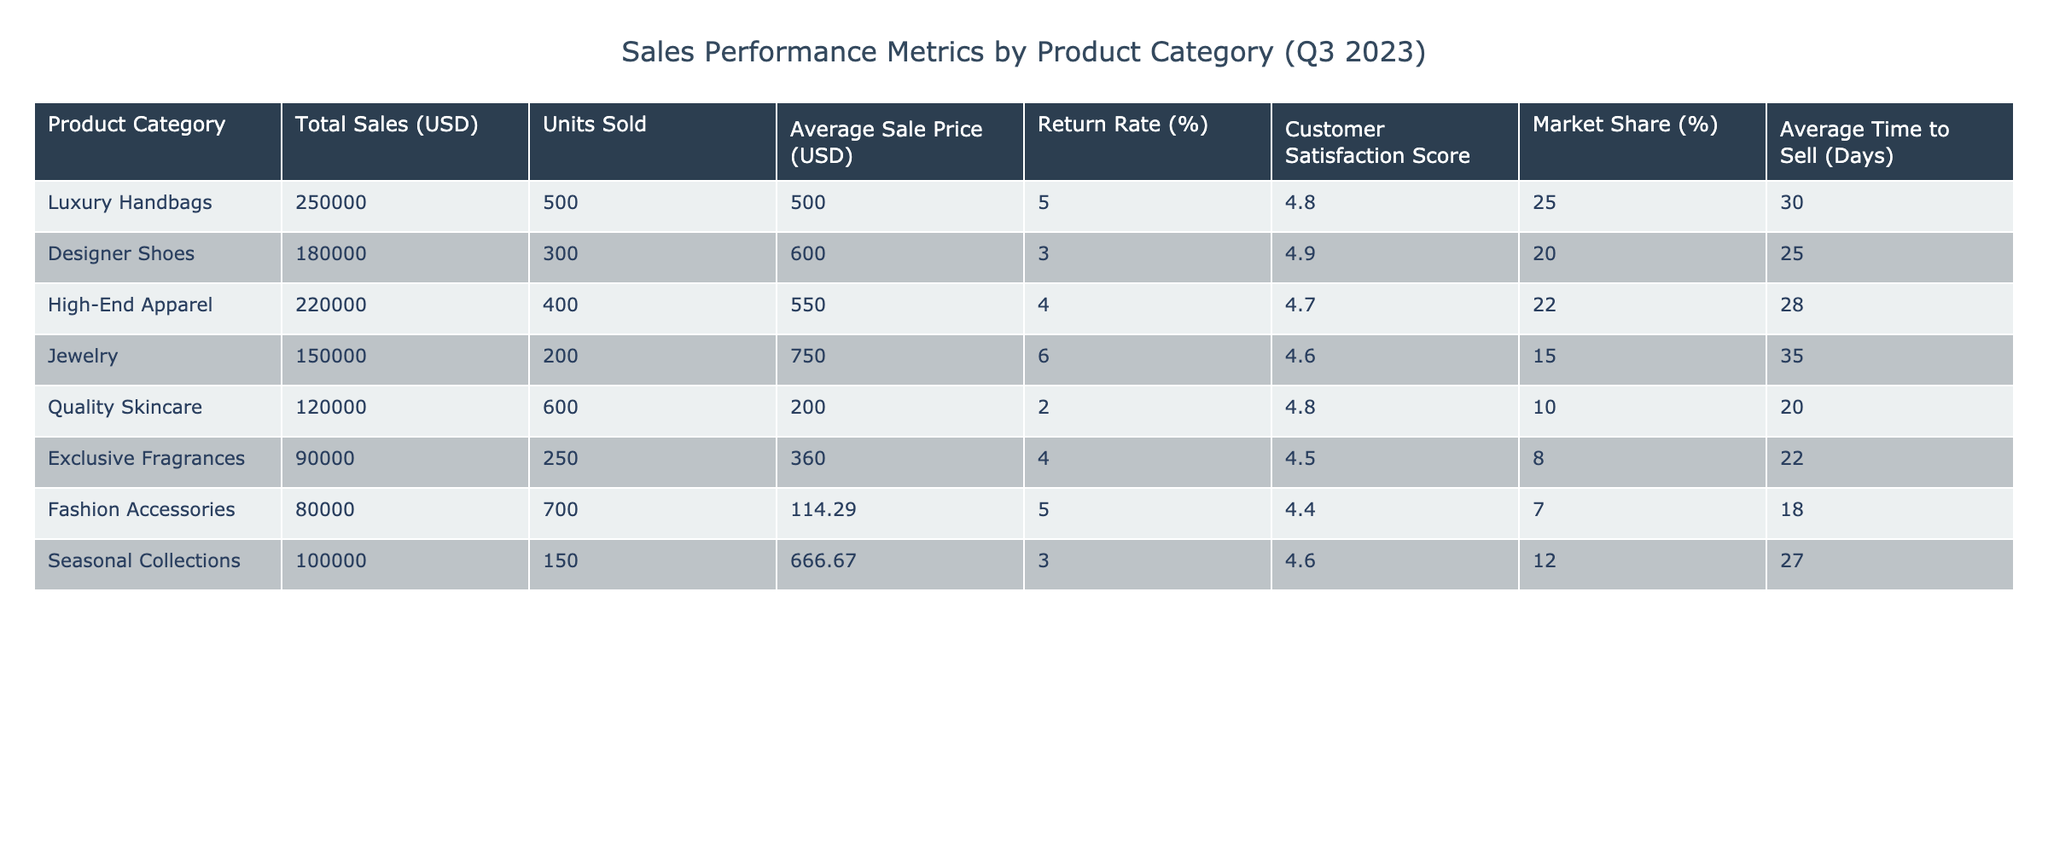What is the total sales for Luxury Handbags? The total sales for Luxury Handbags is listed directly in the table under Total Sales (USD), which shows 250,000.
Answer: 250,000 Which product category has the highest average sale price? To find the highest average sale price, we look at the Average Sale Price (USD) column. The highest value in this column is 750, which corresponds to Jewelry.
Answer: Jewelry What is the return rate for Designer Shoes? The return rate for Designer Shoes is stated in the Return Rate (%) column, which shows a value of 3%.
Answer: 3% What is the average number of units sold across all product categories? To find the average units sold, we sum the Units Sold for all categories (500 + 300 + 400 + 200 + 600 + 250 + 700 + 150 = 3100) and divide by the number of categories (8): 3100/8 = 387.5.
Answer: 387.5 Does the Fashion Accessories category have a higher customer satisfaction score than the Quality Skincare category? We can compare the Customer Satisfaction Score for both categories: Fashion Accessories has a score of 4.4, while Quality Skincare has a score of 4.8. Since 4.4 is less than 4.8, the answer is no.
Answer: No If we combine the total sales of Jewelry and Exclusive Fragrances, how much do we have? The total sales for Jewelry is 150,000 and for Exclusive Fragrances is 90,000. Adding them together, we get 150,000 + 90,000 = 240,000.
Answer: 240,000 What is the market share percentage for High-End Apparel? The market share percentage for High-End Apparel is found in the Market Share (%) column, which shows a value of 22%.
Answer: 22% Which product category sells the most units, and how many units are sold? We look at the Units Sold column and find that Fashion Accessories has the highest number of units sold at 700.
Answer: Fashion Accessories, 700 What is the difference in average sale price between Luxury Handbags and Quality Skincare? The average sale price for Luxury Handbags is 500, and for Quality Skincare, it is 200. To find the difference, we calculate 500 - 200 = 300.
Answer: 300 Which product category has the lowest customer satisfaction score, and what is the score? By checking the Customer Satisfaction Score column, we see that Jewelry has the lowest score at 4.6.
Answer: Jewelry, 4.6 If we consider the average time to sell, which category takes the longest to sell on average? Looking at the Average Time to Sell (Days) column, Jewelry takes the longest to sell, with an average of 35 days.
Answer: Jewelry, 35 days 